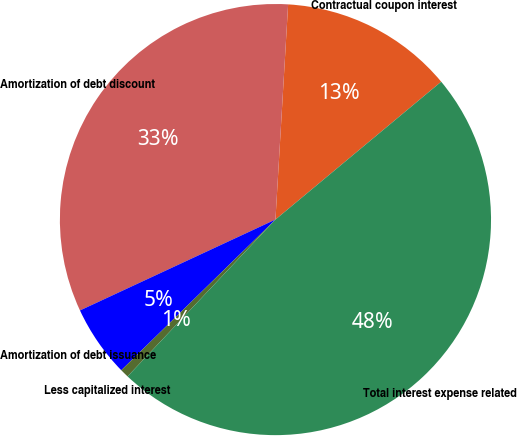Convert chart. <chart><loc_0><loc_0><loc_500><loc_500><pie_chart><fcel>Contractual coupon interest<fcel>Amortization of debt discount<fcel>Amortization of debt issuance<fcel>Less capitalized interest<fcel>Total interest expense related<nl><fcel>13.02%<fcel>32.86%<fcel>5.39%<fcel>0.65%<fcel>48.07%<nl></chart> 